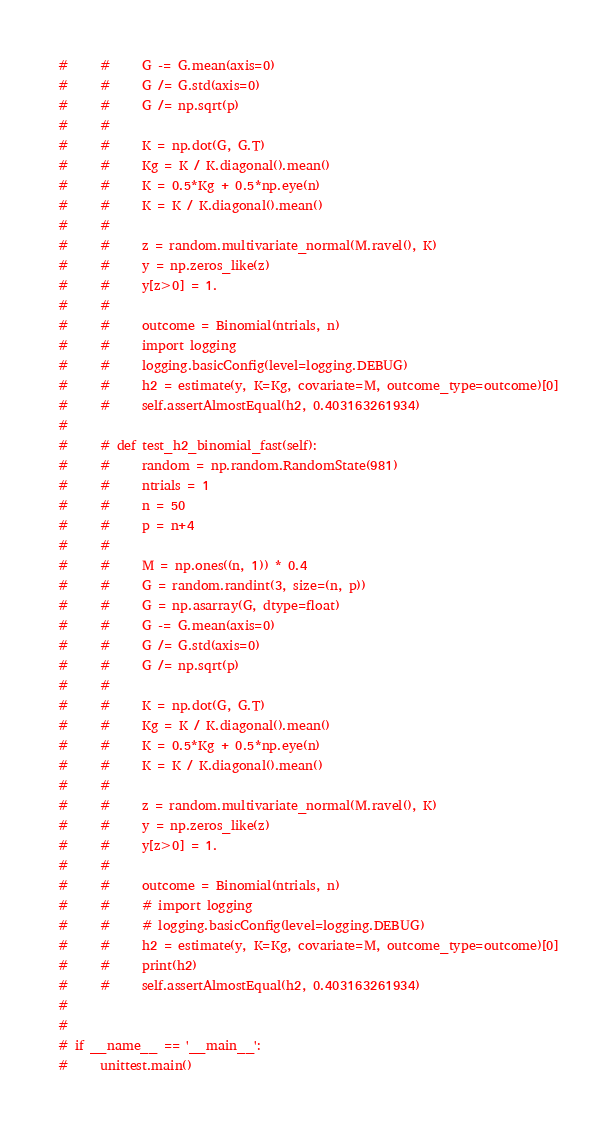Convert code to text. <code><loc_0><loc_0><loc_500><loc_500><_Python_>#     #     G -= G.mean(axis=0)
#     #     G /= G.std(axis=0)
#     #     G /= np.sqrt(p)
#     #
#     #     K = np.dot(G, G.T)
#     #     Kg = K / K.diagonal().mean()
#     #     K = 0.5*Kg + 0.5*np.eye(n)
#     #     K = K / K.diagonal().mean()
#     #
#     #     z = random.multivariate_normal(M.ravel(), K)
#     #     y = np.zeros_like(z)
#     #     y[z>0] = 1.
#     #
#     #     outcome = Binomial(ntrials, n)
#     #     import logging
#     #     logging.basicConfig(level=logging.DEBUG)
#     #     h2 = estimate(y, K=Kg, covariate=M, outcome_type=outcome)[0]
#     #     self.assertAlmostEqual(h2, 0.403163261934)
#
#     # def test_h2_binomial_fast(self):
#     #     random = np.random.RandomState(981)
#     #     ntrials = 1
#     #     n = 50
#     #     p = n+4
#     #
#     #     M = np.ones((n, 1)) * 0.4
#     #     G = random.randint(3, size=(n, p))
#     #     G = np.asarray(G, dtype=float)
#     #     G -= G.mean(axis=0)
#     #     G /= G.std(axis=0)
#     #     G /= np.sqrt(p)
#     #
#     #     K = np.dot(G, G.T)
#     #     Kg = K / K.diagonal().mean()
#     #     K = 0.5*Kg + 0.5*np.eye(n)
#     #     K = K / K.diagonal().mean()
#     #
#     #     z = random.multivariate_normal(M.ravel(), K)
#     #     y = np.zeros_like(z)
#     #     y[z>0] = 1.
#     #
#     #     outcome = Binomial(ntrials, n)
#     #     # import logging
#     #     # logging.basicConfig(level=logging.DEBUG)
#     #     h2 = estimate(y, K=Kg, covariate=M, outcome_type=outcome)[0]
#     #     print(h2)
#     #     self.assertAlmostEqual(h2, 0.403163261934)
#
#
# if __name__ == '__main__':
#     unittest.main()
</code> 